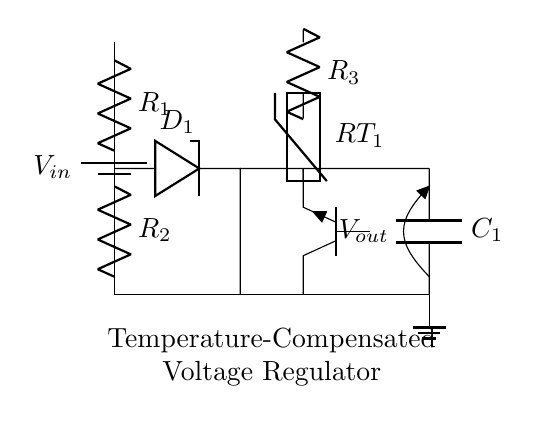What is the function of the Zener diode in this circuit? The Zener diode maintains a stable output voltage by allowing current to flow in the reverse direction once a certain voltage is exceeded. It clamps the voltage across it to its breakdown voltage, ensuring that the output voltage does not exceed this level during operation.
Answer: Voltage regulation What type of transistor is used in this circuit? The circuit shows a NPN transistor, which is identified by the symbol and the label "Tnpn." NPN transistors are commonly used for switching and amplification in voltage regulation circuits.
Answer: NPN What role does the thermistor play in this circuit? The thermistor is used for temperature compensation, which means it changes resistance with temperature. This property helps adjust the output voltage of the regulator in response to temperature changes, ensuring stable operation no matter the environmental conditions.
Answer: Temperature compensation How many resistors can be found in the circuit? The circuit diagram includes two explicitly labeled resistors: R1 and R3, as well as one thermistor, which functions as a resistor. Hence, there are a total of three resistive components in the circuit.
Answer: Three What components are involved in the voltage divider? The voltage divider consists of two resistors: R1 and R2, which are connected in series. This configuration divides the input voltage into smaller output voltages, which is essential for providing the correct biasing for the Zener diode and transistor in the regulator circuit.
Answer: R1 and R2 What is the purpose of the output capacitor? The output capacitor, C1, is used to smooth out the voltage by storing charge and providing stable output under varying loads. It reduces voltage fluctuations and helps maintain a consistent voltage level at the output.
Answer: Smoothing voltage 